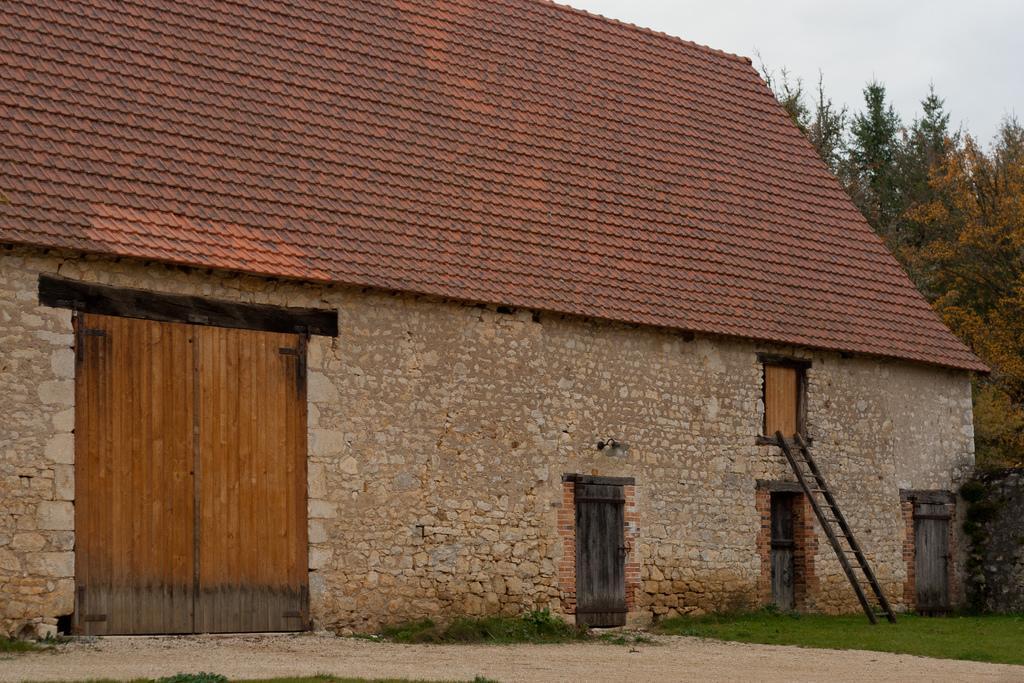Please provide a concise description of this image. In this image we can see the house, ladder, grass, path, wall, trees and also the sky. 